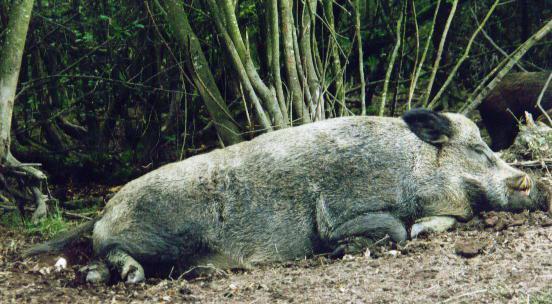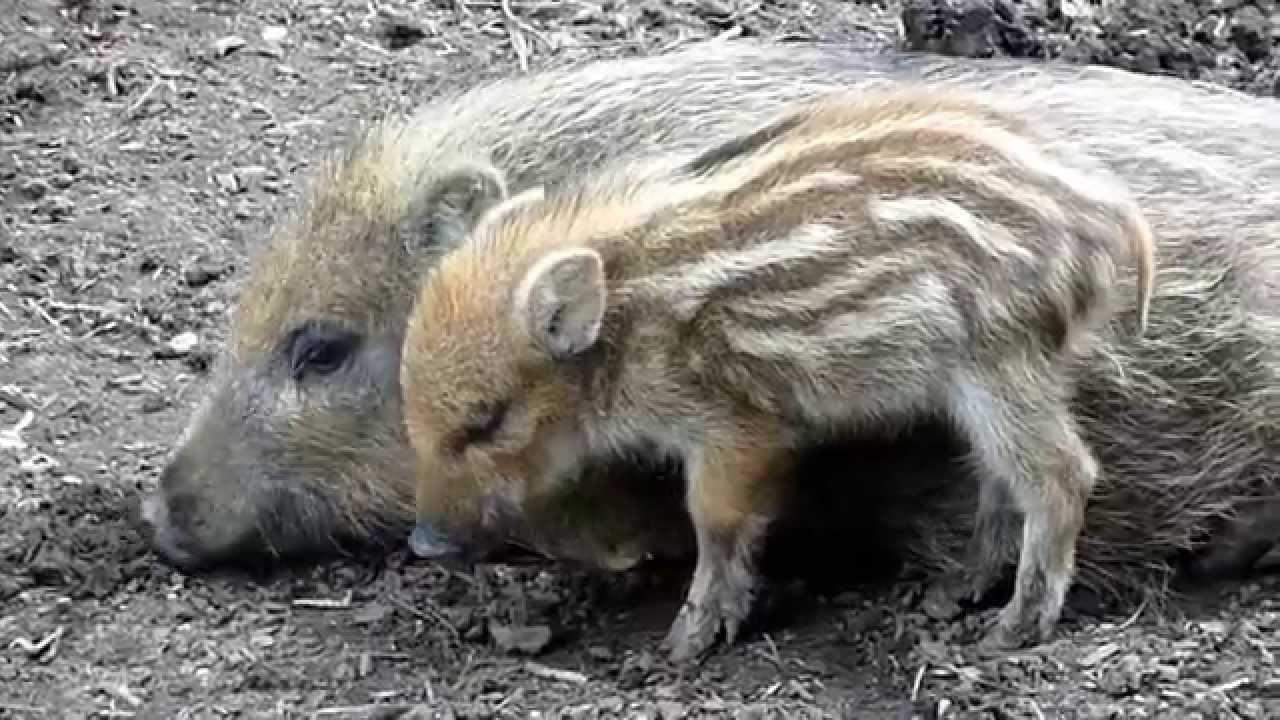The first image is the image on the left, the second image is the image on the right. Assess this claim about the two images: "The left image contains exactly one boar.". Correct or not? Answer yes or no. Yes. The first image is the image on the left, the second image is the image on the right. Analyze the images presented: Is the assertion "An image shows at least two baby piglets with distinctive striped fur lying in front of an older wild pig that is lying on its side." valid? Answer yes or no. No. 